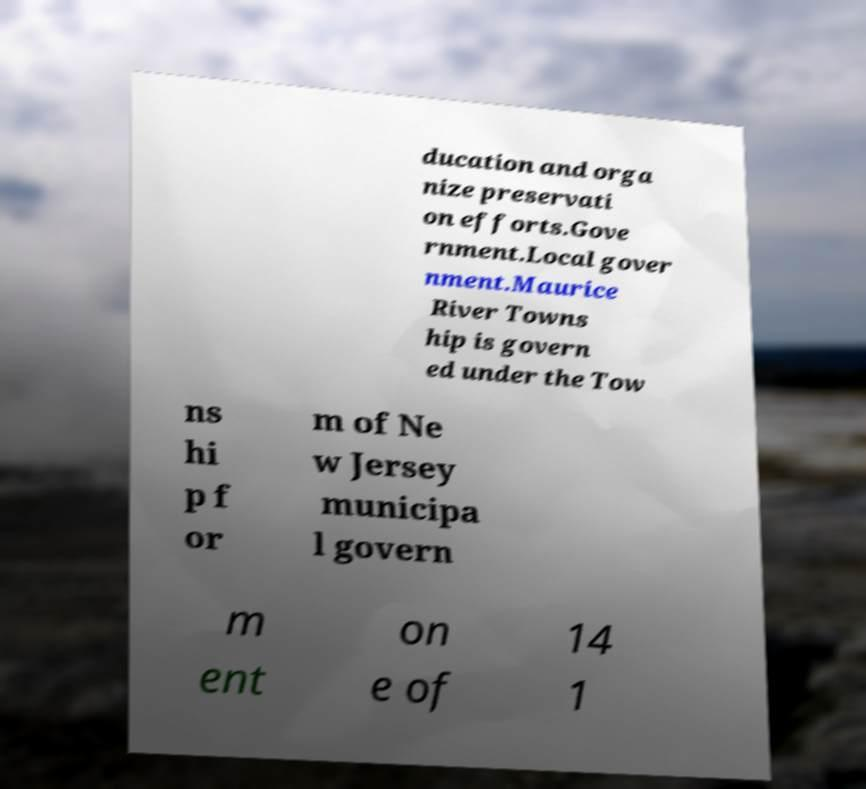Please identify and transcribe the text found in this image. ducation and orga nize preservati on efforts.Gove rnment.Local gover nment.Maurice River Towns hip is govern ed under the Tow ns hi p f or m of Ne w Jersey municipa l govern m ent on e of 14 1 